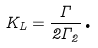Convert formula to latex. <formula><loc_0><loc_0><loc_500><loc_500>K _ { L } = \frac { \Gamma } { 2 \Gamma _ { 2 } } \text {.}</formula> 